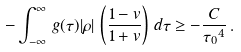<formula> <loc_0><loc_0><loc_500><loc_500>- \int _ { - \infty } ^ { \infty } \, g ( \tau ) | \rho | \, \left ( \frac { 1 - v } { 1 + v } \right ) \, d \tau \geq - \frac { C } { { \tau _ { 0 } } ^ { 4 } } \, .</formula> 